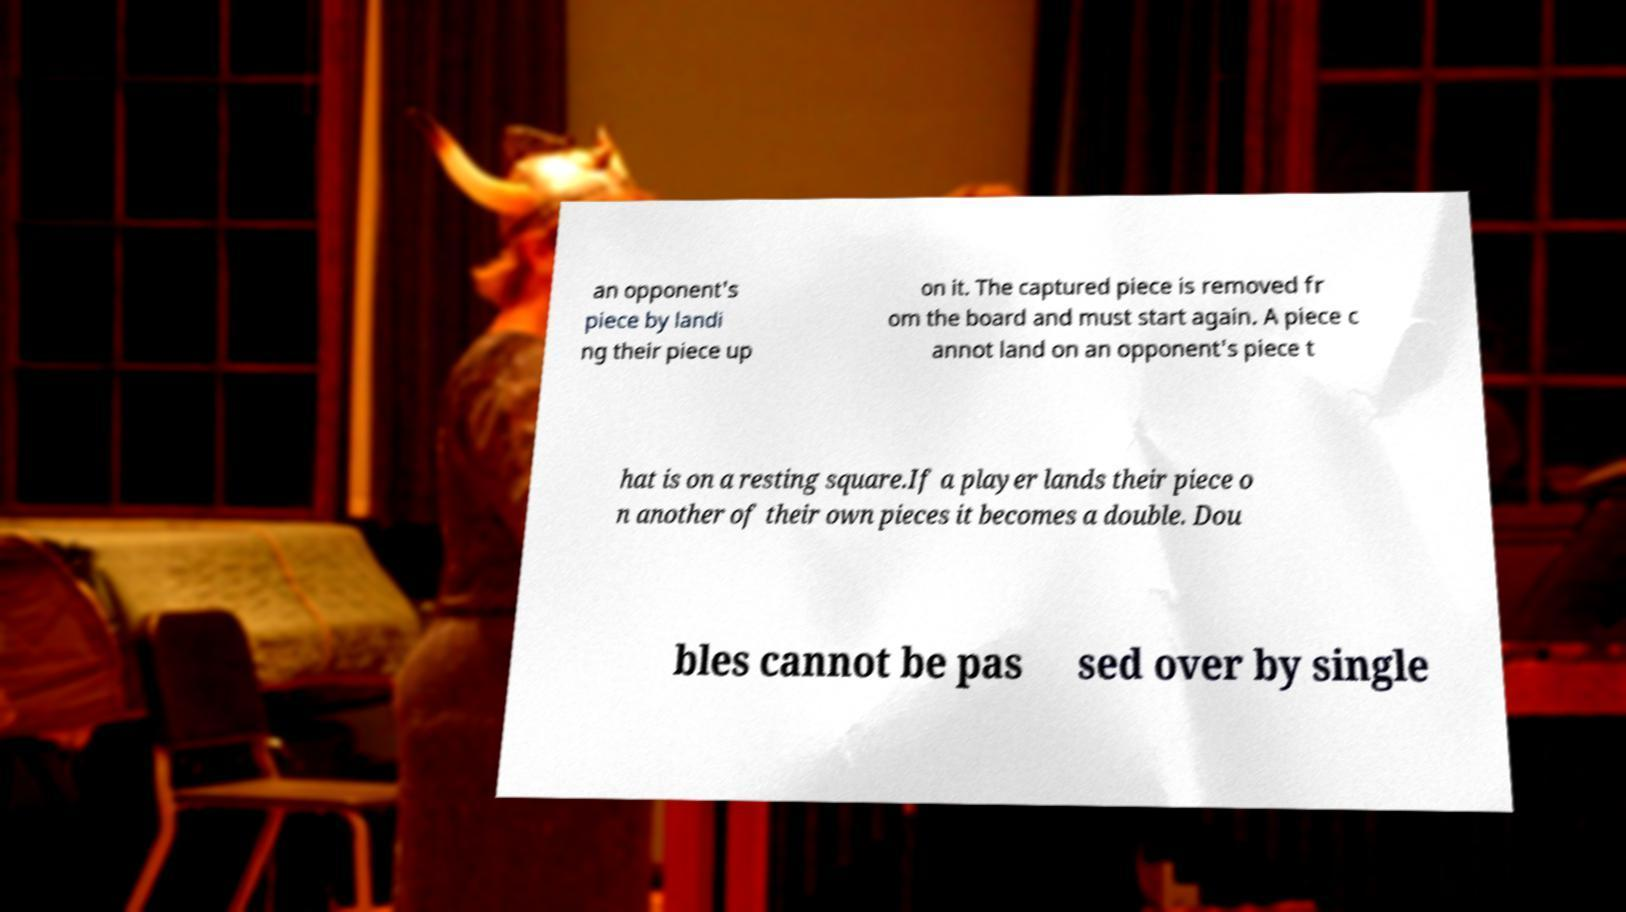Please read and relay the text visible in this image. What does it say? an opponent's piece by landi ng their piece up on it. The captured piece is removed fr om the board and must start again. A piece c annot land on an opponent's piece t hat is on a resting square.If a player lands their piece o n another of their own pieces it becomes a double. Dou bles cannot be pas sed over by single 